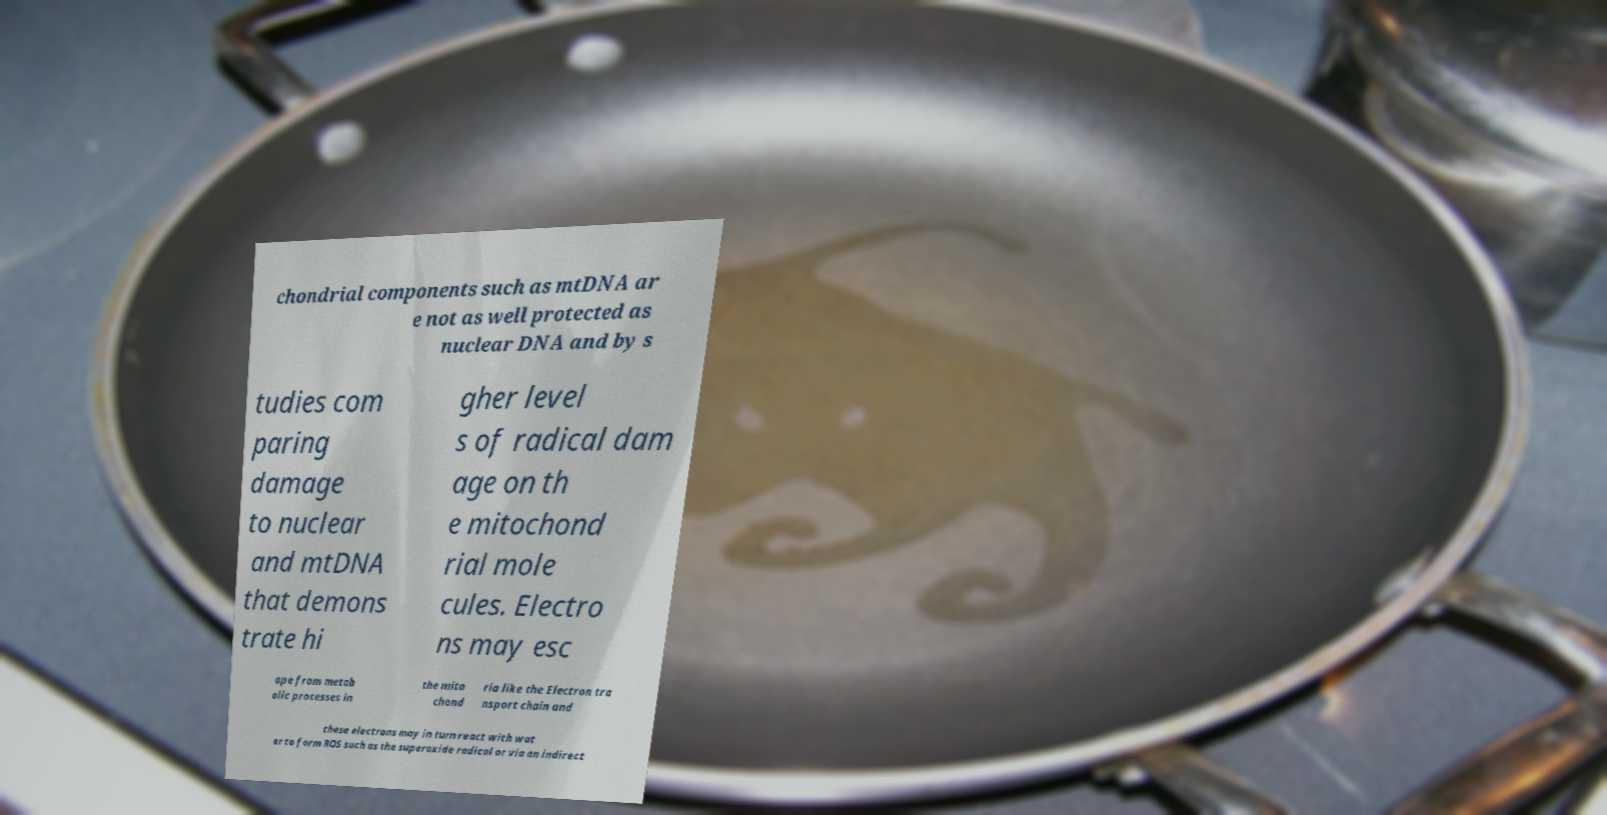Can you accurately transcribe the text from the provided image for me? chondrial components such as mtDNA ar e not as well protected as nuclear DNA and by s tudies com paring damage to nuclear and mtDNA that demons trate hi gher level s of radical dam age on th e mitochond rial mole cules. Electro ns may esc ape from metab olic processes in the mito chond ria like the Electron tra nsport chain and these electrons may in turn react with wat er to form ROS such as the superoxide radical or via an indirect 